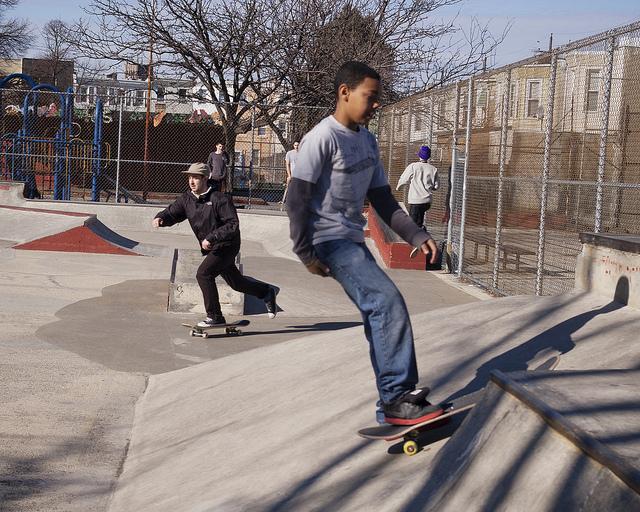What are they doing?
Be succinct. Skateboarding. Is the man wearing black jacket?
Short answer required. Yes. What is the racial background of the kid in the foreground?
Concise answer only. Black. What color shirt is the boy in front wearing?
Short answer required. Gray. 